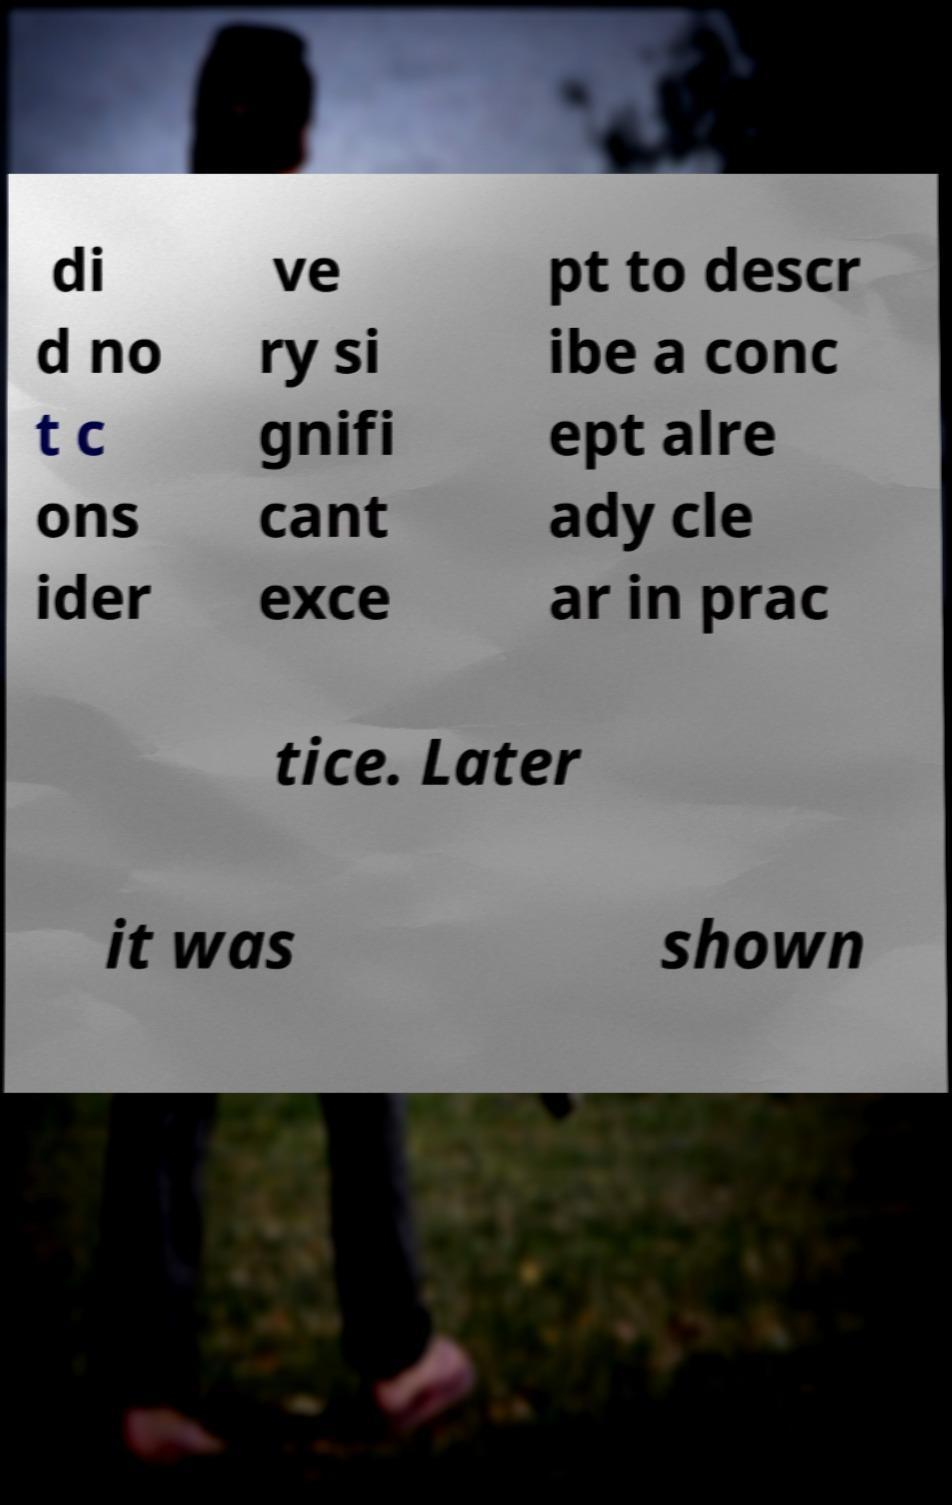There's text embedded in this image that I need extracted. Can you transcribe it verbatim? di d no t c ons ider ve ry si gnifi cant exce pt to descr ibe a conc ept alre ady cle ar in prac tice. Later it was shown 